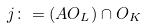<formula> <loc_0><loc_0><loc_500><loc_500>j \colon = ( A O _ { L } ) \cap O _ { K }</formula> 